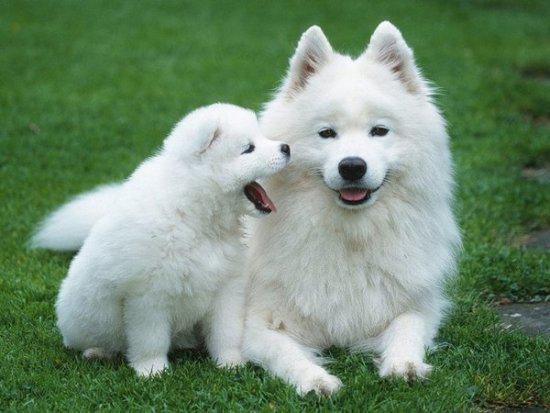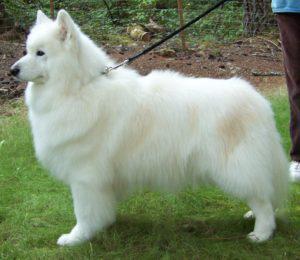The first image is the image on the left, the second image is the image on the right. For the images displayed, is the sentence "There are exactly three dogs in total." factually correct? Answer yes or no. Yes. The first image is the image on the left, the second image is the image on the right. Analyze the images presented: Is the assertion "Two white dogs are playing with a toy." valid? Answer yes or no. No. 